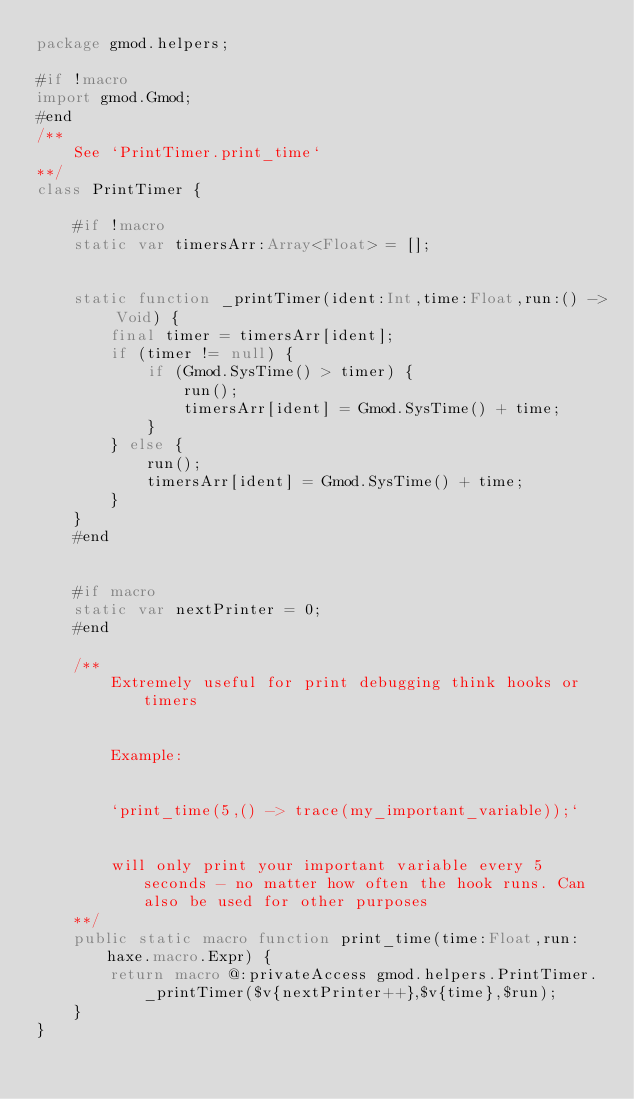<code> <loc_0><loc_0><loc_500><loc_500><_Haxe_>package gmod.helpers;

#if !macro
import gmod.Gmod;
#end
/**
    See `PrintTimer.print_time`
**/
class PrintTimer {

    #if !macro
    static var timersArr:Array<Float> = [];

    
    static function _printTimer(ident:Int,time:Float,run:() -> Void) {
        final timer = timersArr[ident];
        if (timer != null) {
            if (Gmod.SysTime() > timer) {
                run();
                timersArr[ident] = Gmod.SysTime() + time;
            }
        } else {
            run();
            timersArr[ident] = Gmod.SysTime() + time;
        }
    }
    #end


    #if macro
    static var nextPrinter = 0;
    #end

    /**
        Extremely useful for print debugging think hooks or timers
        
        
        Example:


        `print_time(5,() -> trace(my_important_variable));`
        
        
        will only print your important variable every 5 seconds - no matter how often the hook runs. Can also be used for other purposes
    **/
    public static macro function print_time(time:Float,run:haxe.macro.Expr) {
        return macro @:privateAccess gmod.helpers.PrintTimer._printTimer($v{nextPrinter++},$v{time},$run);
    }
}
</code> 